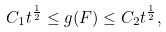<formula> <loc_0><loc_0><loc_500><loc_500>C _ { 1 } t ^ { \frac { 1 } { 2 } } \leq g ( F ) \leq C _ { 2 } t ^ { \frac { 1 } { 2 } } ,</formula> 